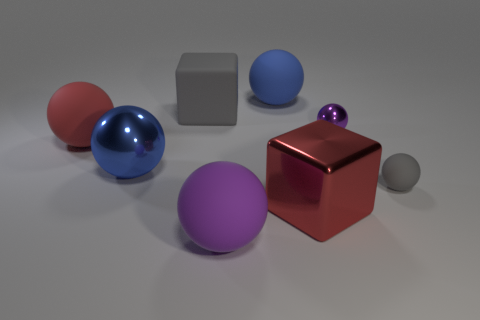Subtract all gray spheres. How many spheres are left? 5 Subtract all large shiny balls. How many balls are left? 5 Subtract all red blocks. Subtract all cyan balls. How many blocks are left? 1 Add 2 big gray cubes. How many objects exist? 10 Subtract all spheres. How many objects are left? 2 Subtract 0 blue cylinders. How many objects are left? 8 Subtract all large purple rubber blocks. Subtract all small gray matte spheres. How many objects are left? 7 Add 3 big purple matte balls. How many big purple matte balls are left? 4 Add 1 big rubber cubes. How many big rubber cubes exist? 2 